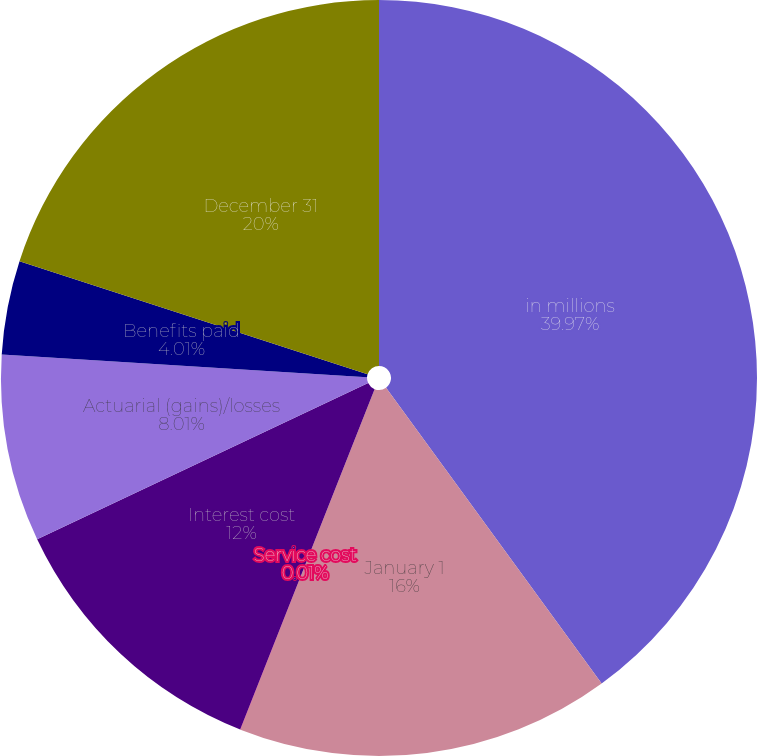Convert chart. <chart><loc_0><loc_0><loc_500><loc_500><pie_chart><fcel>in millions<fcel>January 1<fcel>Service cost<fcel>Interest cost<fcel>Actuarial (gains)/losses<fcel>Benefits paid<fcel>December 31<nl><fcel>39.98%<fcel>16.0%<fcel>0.01%<fcel>12.0%<fcel>8.01%<fcel>4.01%<fcel>20.0%<nl></chart> 